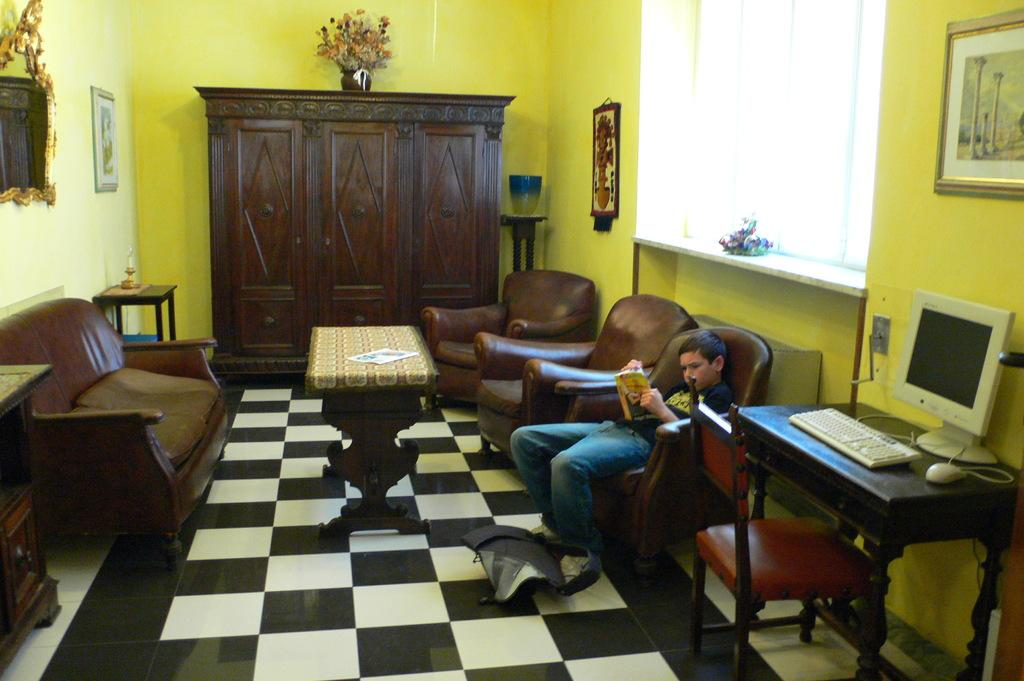What is the boy doing in the image? The boy is sitting on a chair on the floor. What furniture is present in the image besides the chair? There is a cupboard and a table in the image. What electronic device can be seen in the image? There is a computer in the image. What architectural feature is visible in the image? There is a window in the image. What type of pipe is visible in the image? There is no pipe present in the image. 